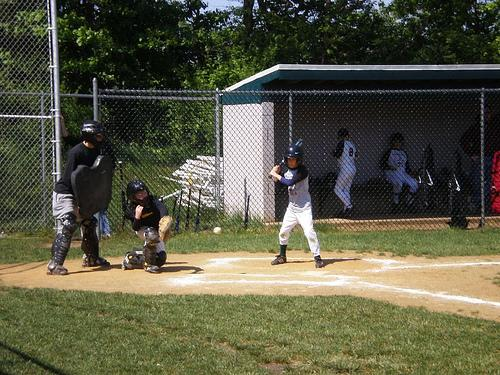Where do those who await their turn at bat wait? dugout 